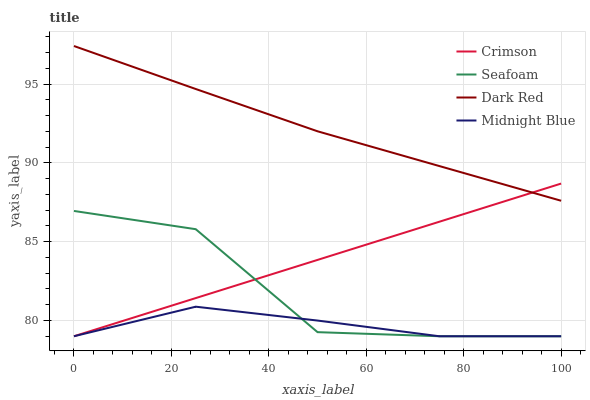Does Seafoam have the minimum area under the curve?
Answer yes or no. No. Does Seafoam have the maximum area under the curve?
Answer yes or no. No. Is Dark Red the smoothest?
Answer yes or no. No. Is Dark Red the roughest?
Answer yes or no. No. Does Dark Red have the lowest value?
Answer yes or no. No. Does Seafoam have the highest value?
Answer yes or no. No. Is Seafoam less than Dark Red?
Answer yes or no. Yes. Is Dark Red greater than Seafoam?
Answer yes or no. Yes. Does Seafoam intersect Dark Red?
Answer yes or no. No. 